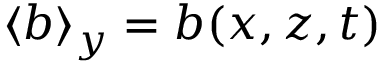Convert formula to latex. <formula><loc_0><loc_0><loc_500><loc_500>\langle b \rangle _ { y } = b ( x , z , t )</formula> 